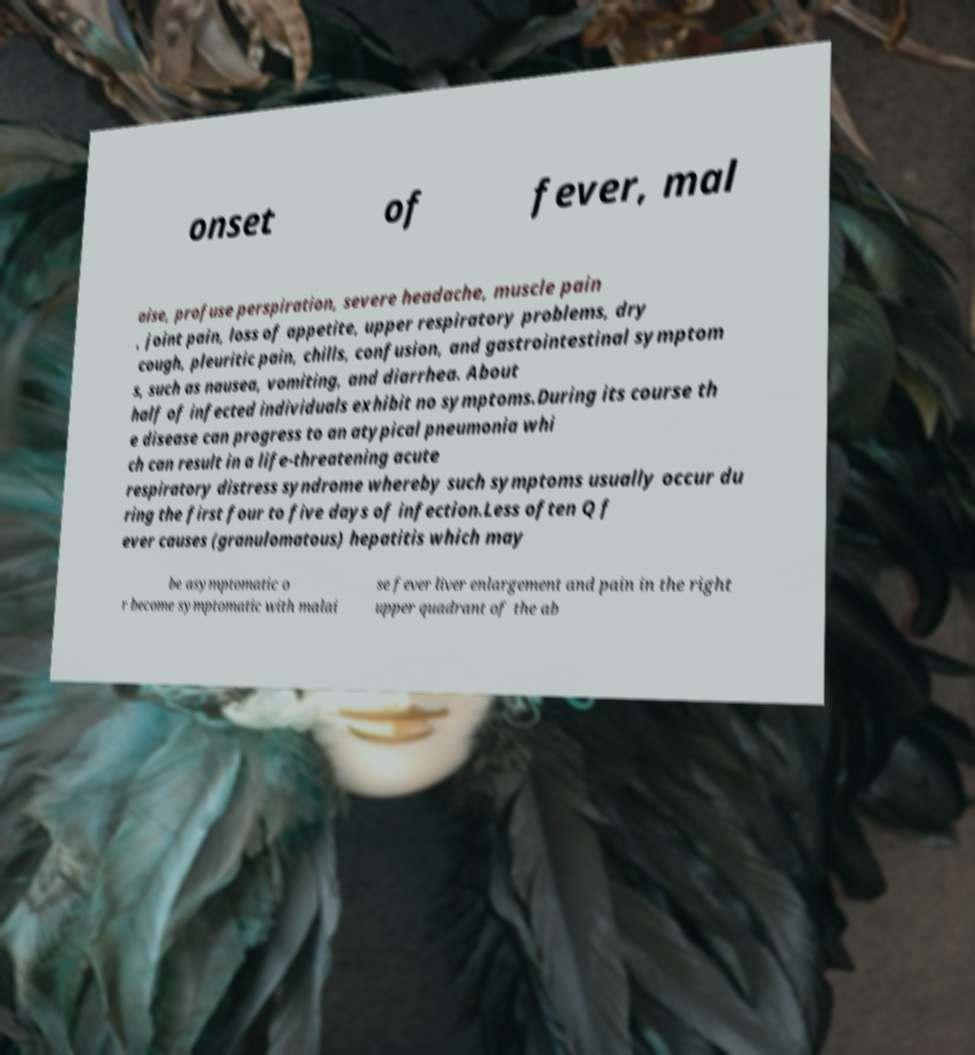Please read and relay the text visible in this image. What does it say? onset of fever, mal aise, profuse perspiration, severe headache, muscle pain , joint pain, loss of appetite, upper respiratory problems, dry cough, pleuritic pain, chills, confusion, and gastrointestinal symptom s, such as nausea, vomiting, and diarrhea. About half of infected individuals exhibit no symptoms.During its course th e disease can progress to an atypical pneumonia whi ch can result in a life-threatening acute respiratory distress syndrome whereby such symptoms usually occur du ring the first four to five days of infection.Less often Q f ever causes (granulomatous) hepatitis which may be asymptomatic o r become symptomatic with malai se fever liver enlargement and pain in the right upper quadrant of the ab 